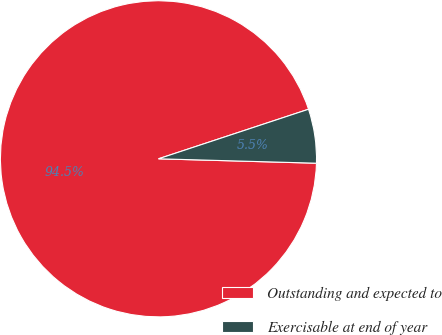Convert chart to OTSL. <chart><loc_0><loc_0><loc_500><loc_500><pie_chart><fcel>Outstanding and expected to<fcel>Exercisable at end of year<nl><fcel>94.48%<fcel>5.52%<nl></chart> 